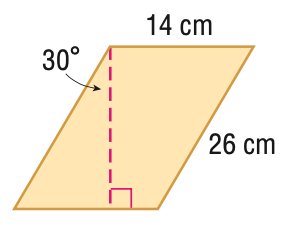Question: Find the area of the parallelogram. Round to the nearest tenth if necessary.
Choices:
A. 80.0
B. 157.6
C. 315.2
D. 364.0
Answer with the letter. Answer: C 